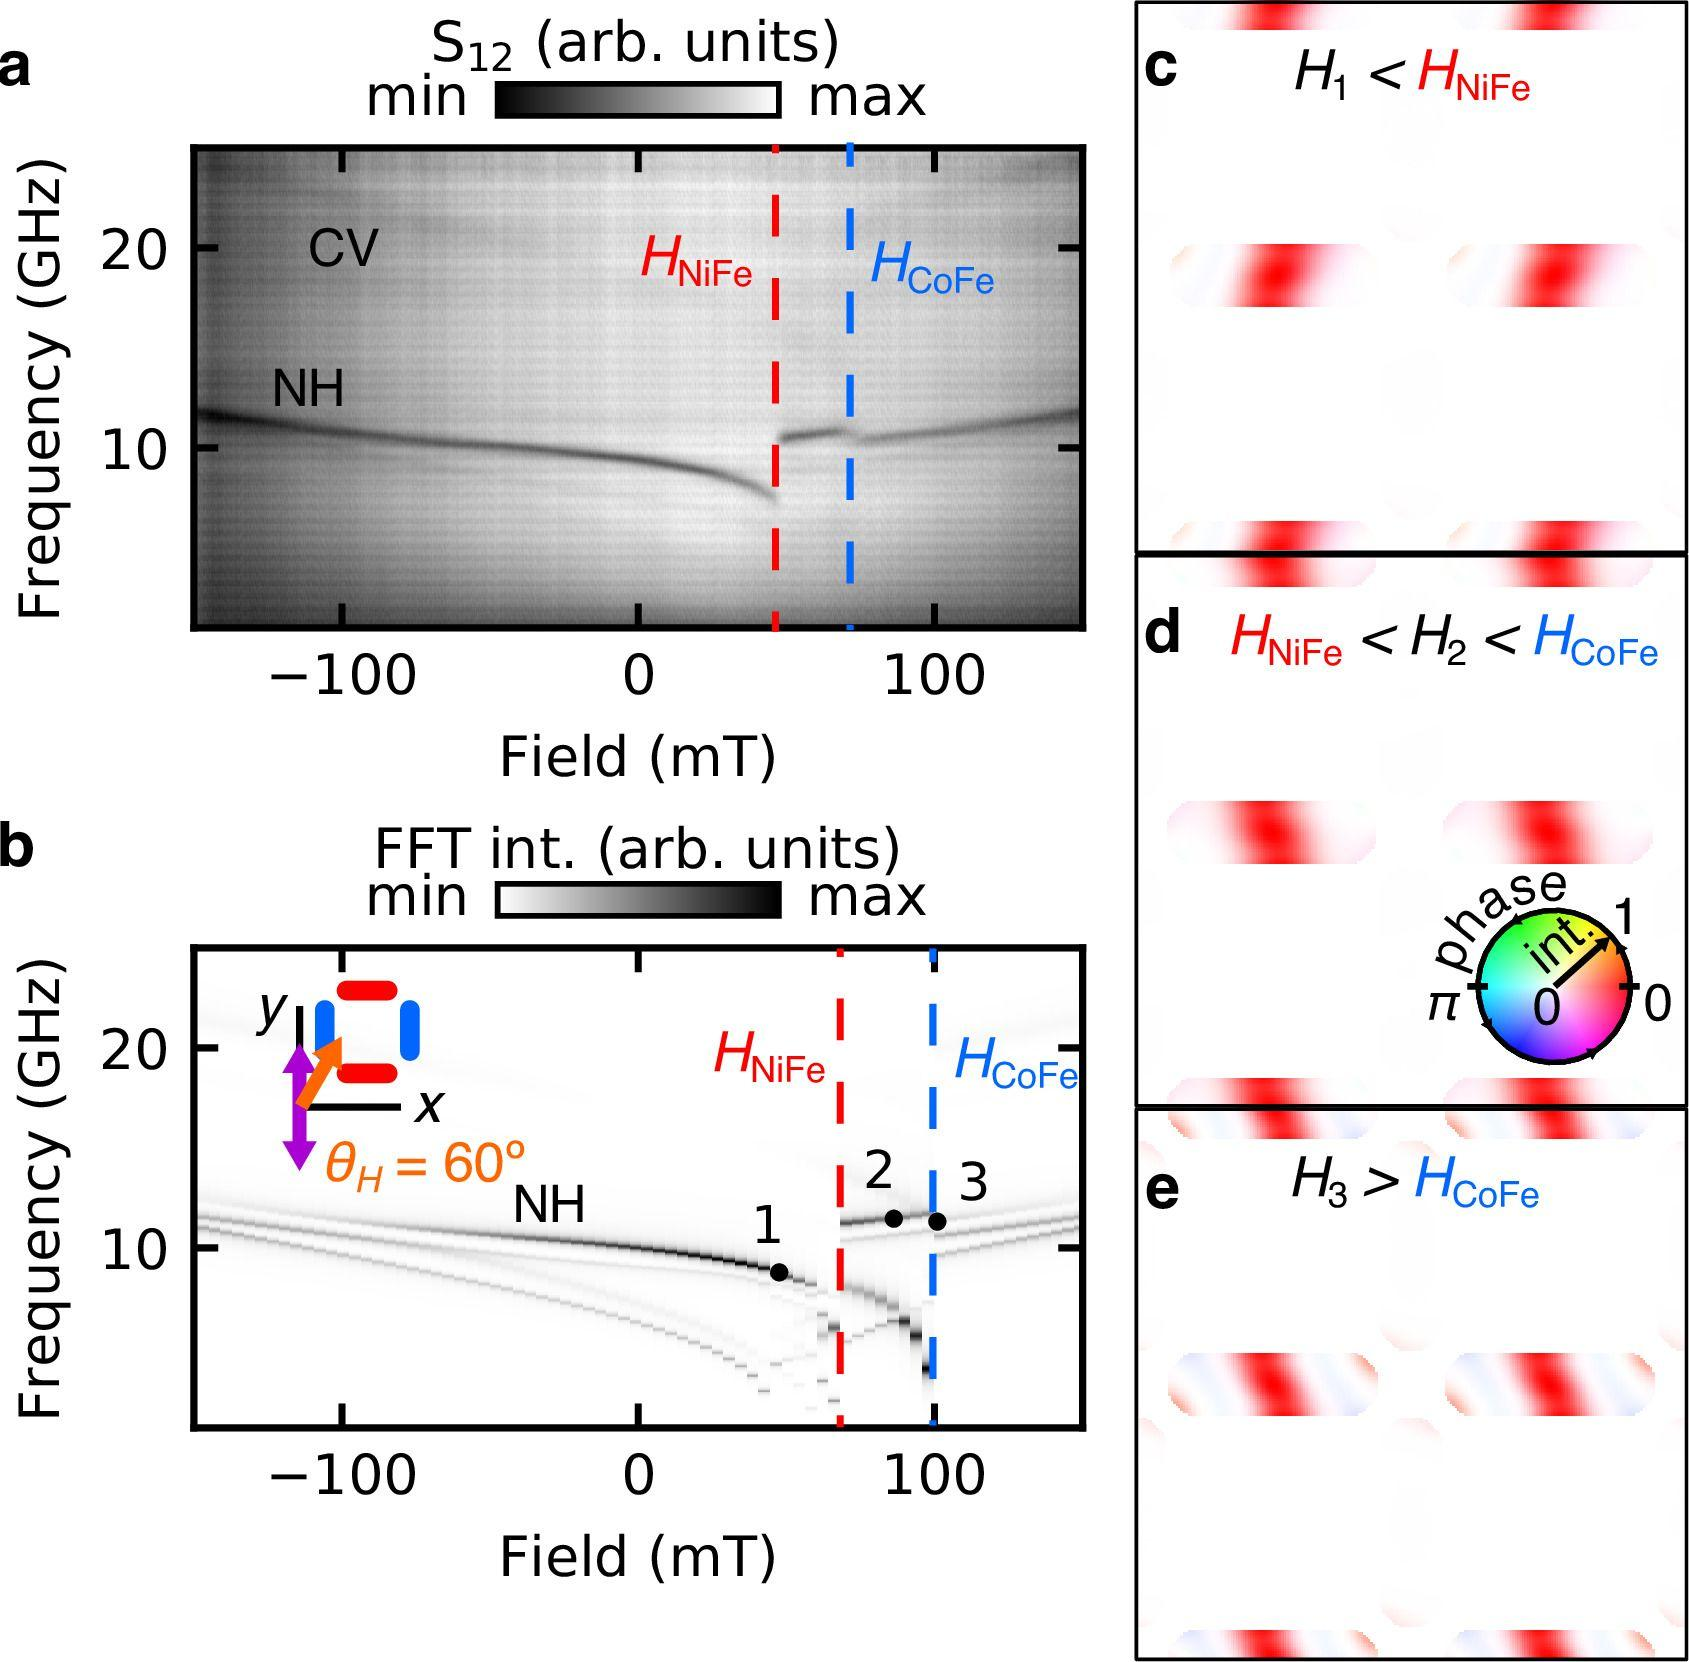How could the information from panels a and b complement the data seen in panels c, d, and e concerning magnetic field strengths? Panels a and b illustrate the background and setup conditions which facilitate the understanding of the behavior shown in panels c, d, and e. Specifically, panel a shows a broad spectrum and indicates where \( H_{NiFe} \) and \( H_{CoFe} \) are located amidst other frequencies and field strengths. Panel b details the angles and response curves, giving context to how the measurement conditions can affect the observed field strengths in c, d, and e, thus providing a comprehensive view of the interactions and dependencies among the magnetic properties exhibited. 